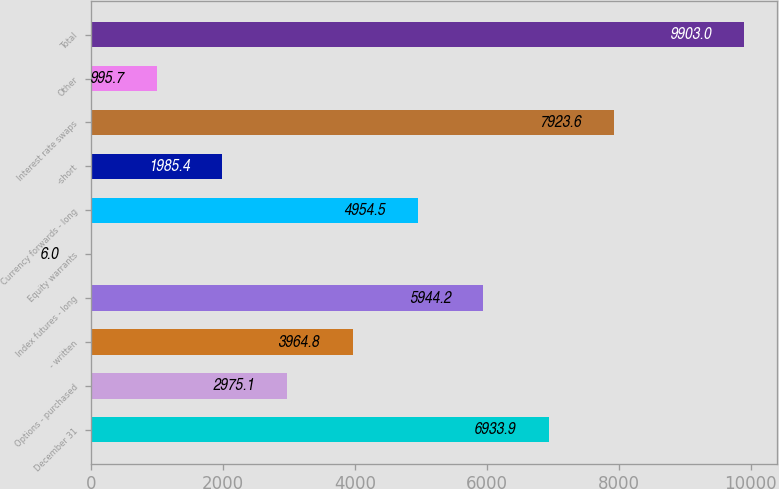Convert chart to OTSL. <chart><loc_0><loc_0><loc_500><loc_500><bar_chart><fcel>December 31<fcel>Options - purchased<fcel>- written<fcel>Index futures - long<fcel>Equity warrants<fcel>Currency forwards - long<fcel>-short<fcel>Interest rate swaps<fcel>Other<fcel>Total<nl><fcel>6933.9<fcel>2975.1<fcel>3964.8<fcel>5944.2<fcel>6<fcel>4954.5<fcel>1985.4<fcel>7923.6<fcel>995.7<fcel>9903<nl></chart> 